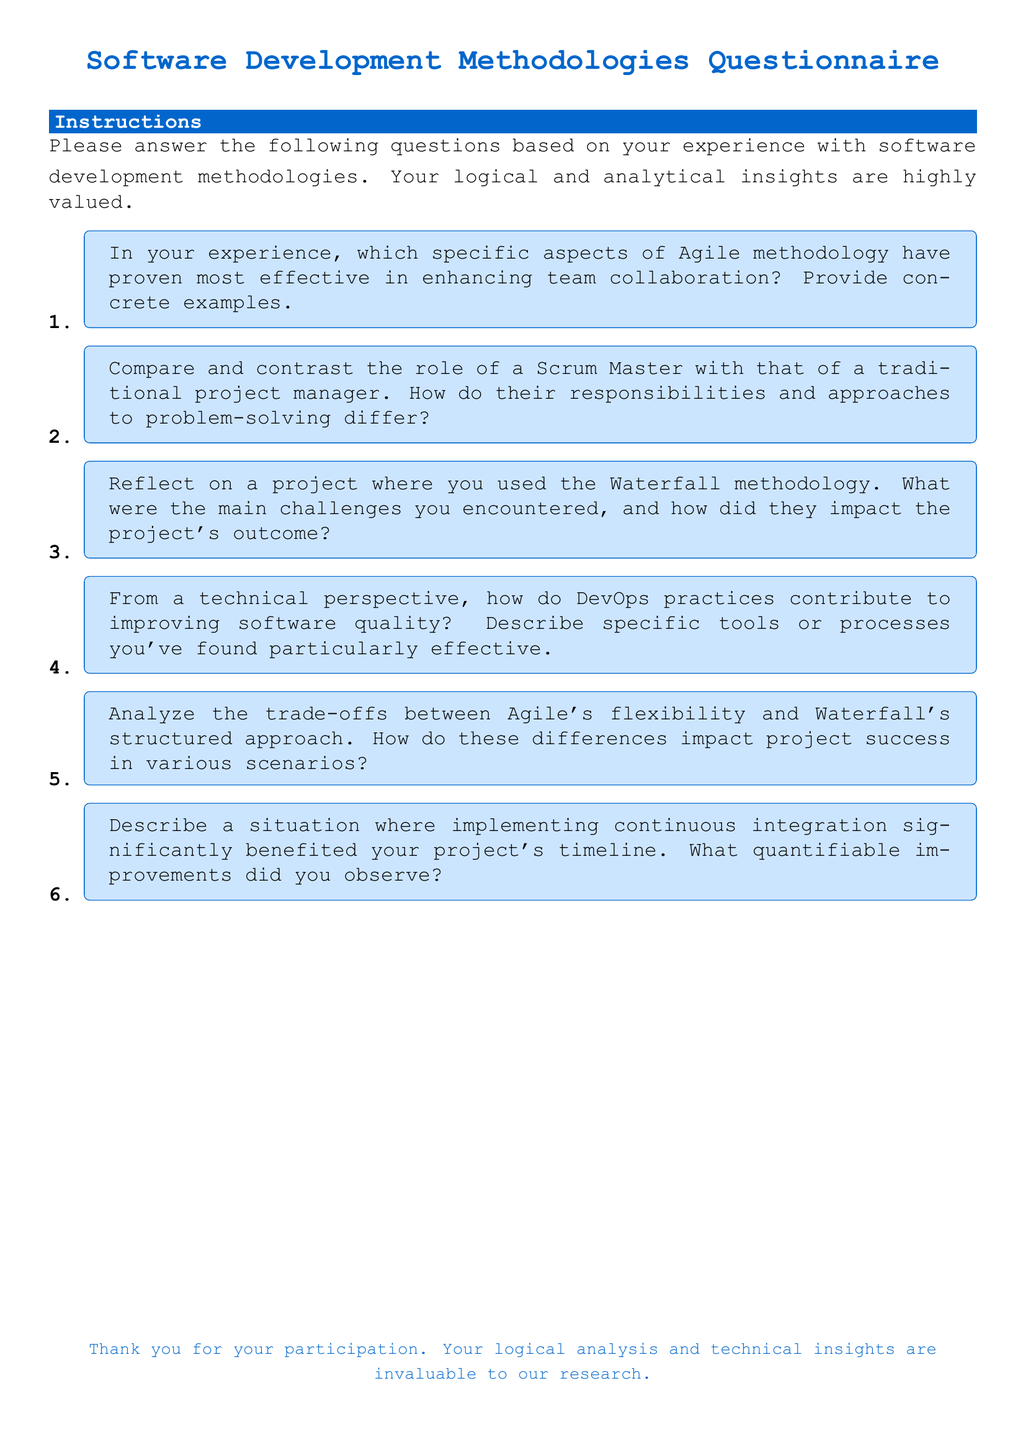What is the main color used in the document? The main color is specified in the document's code and is used for titles and text elements, which is RGB code 0,102,204.
Answer: RGB(0, 102, 204) How many questions are in the questionnaire? The document lists a total of six questions focusing on software development methodologies.
Answer: 6 What methodology is mentioned in the first question? The first question specifically references Agile methodology and its effectiveness in enhancing team collaboration.
Answer: Agile What two methodologies are compared in question five? The question addresses the trade-offs between Agile’s flexibility and Waterfall’s structured approach in project success scenarios.
Answer: Agile and Waterfall What is the purpose of the questionnaire as stated in the document? The purpose is for participants to answer questions based on their experiences with software development methodologies, emphasizing logical and analytical insights.
Answer: Research Who is responsible for answering the questions in the document? The questions are directed toward individuals with experience in software development methodologies who can provide insights based on their experiences.
Answer: Participants 